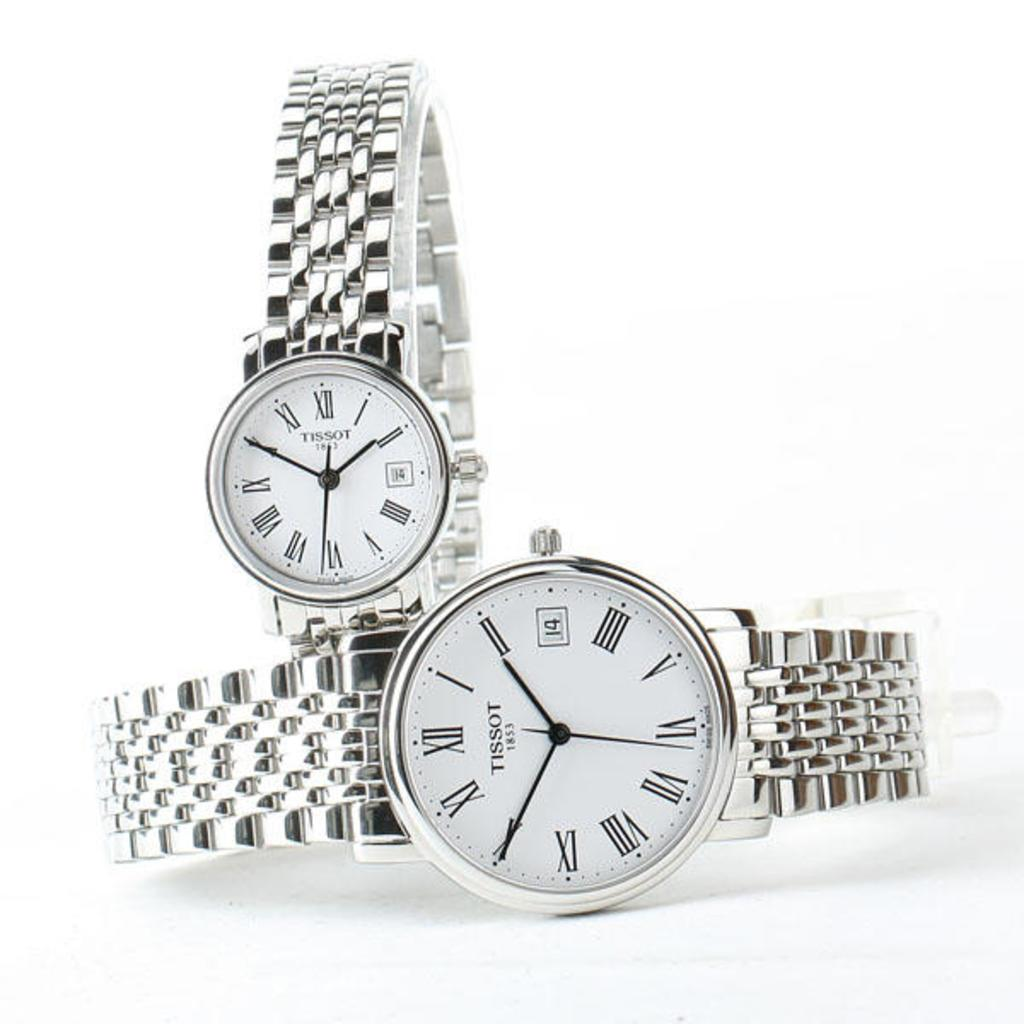<image>
Share a concise interpretation of the image provided. Two Chrome TISSO 1853 watches perpendicular to each other. 